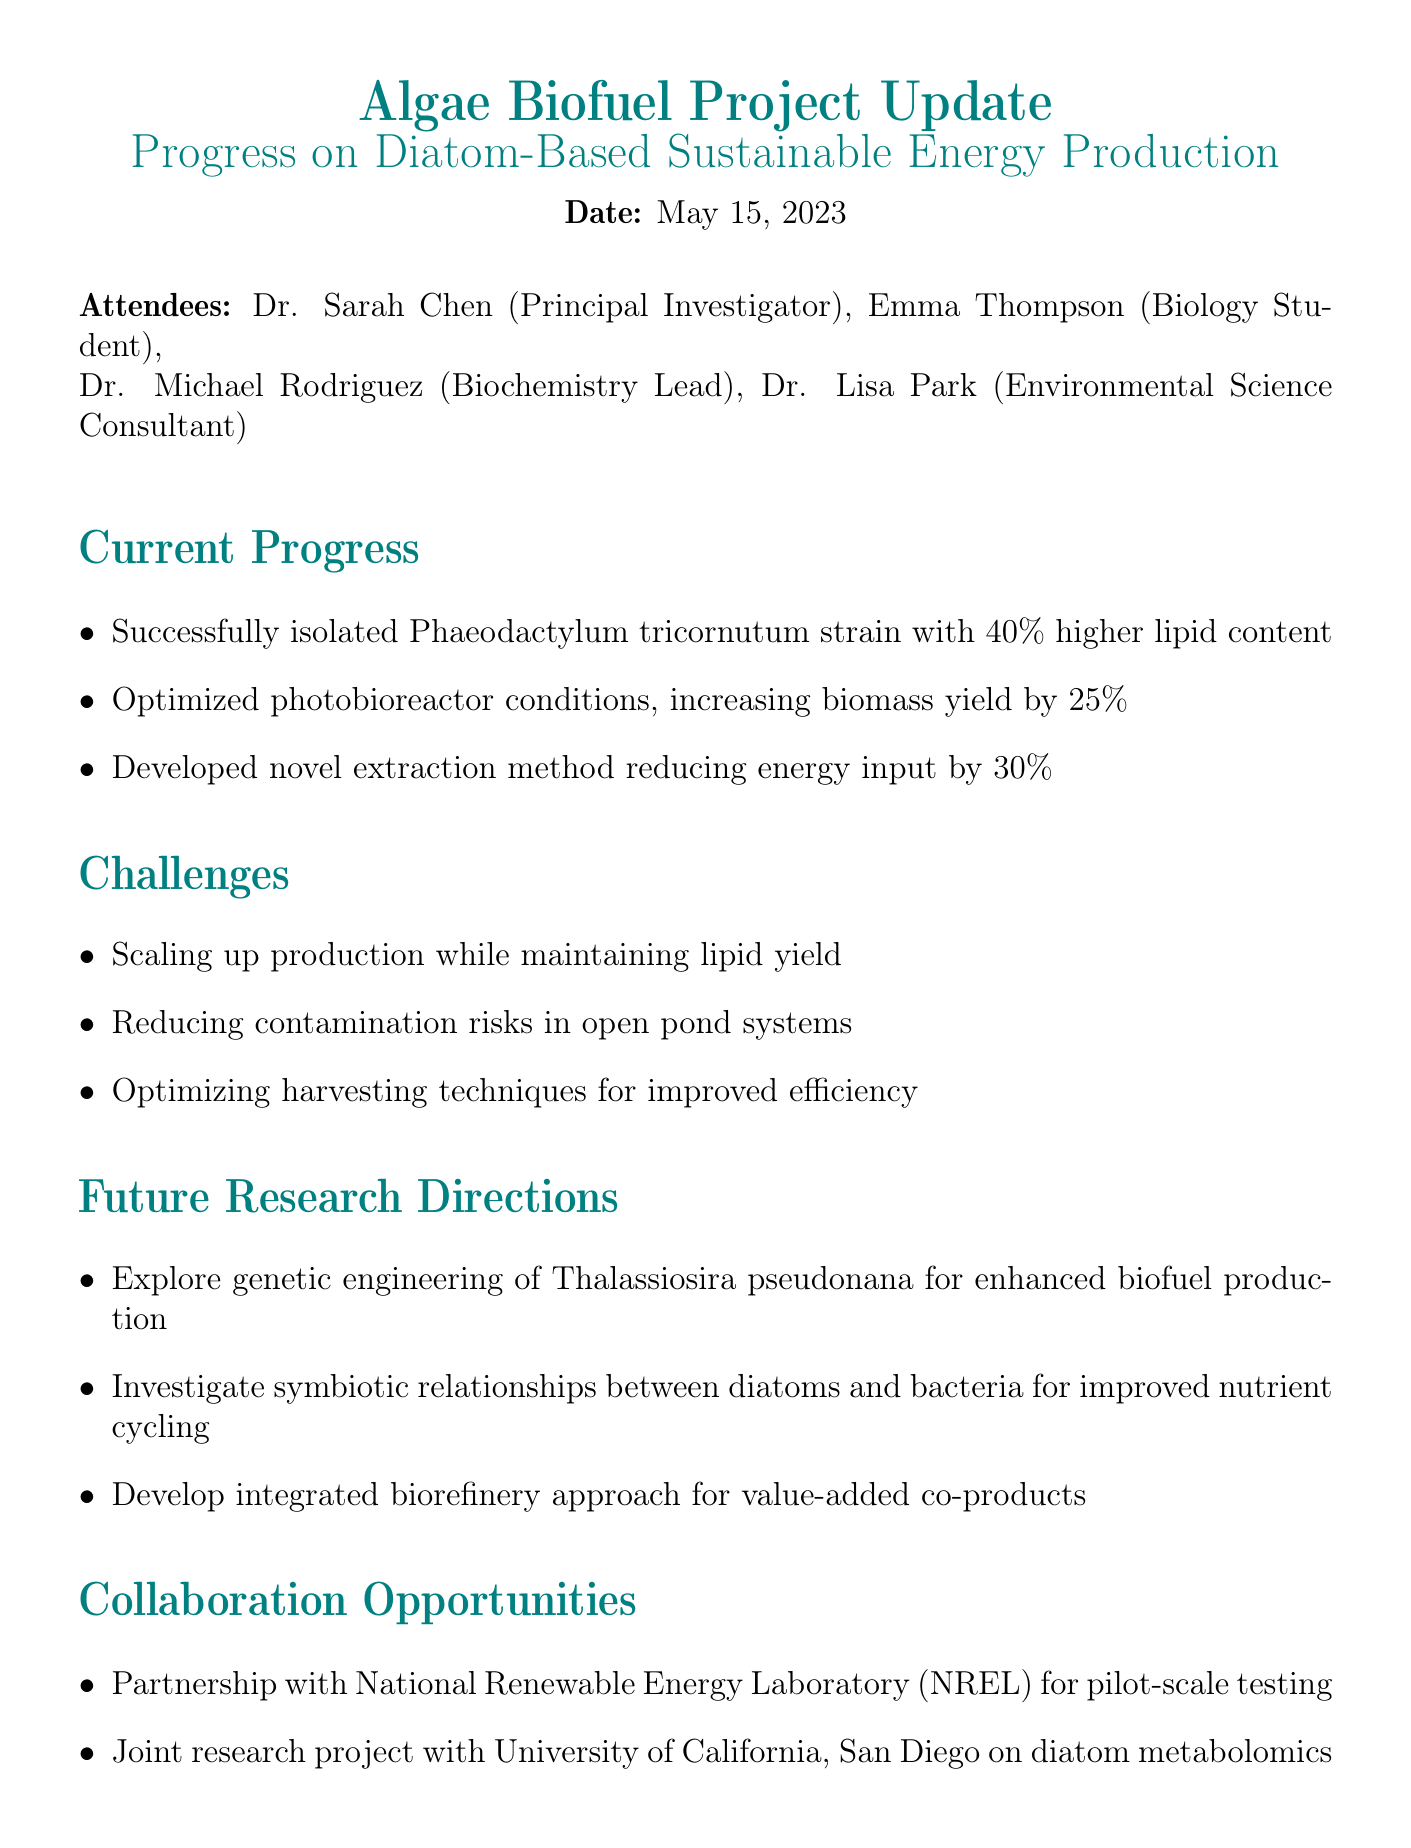What is the date of the meeting? The date of the meeting is explicitly stated in the document.
Answer: May 15, 2023 Who is the Principal Investigator? The document lists attendees, where the Principal Investigator is specifically identified.
Answer: Dr. Sarah Chen What strain of diatom was successfully isolated? The current progress section mentions this specific strain.
Answer: Phaeodactylum tricornutum By what percentage was the biomass yield increased? The increase in biomass yield is detailed in the current progress section.
Answer: 25% What is one of the challenges mentioned in the document? The challenges section lists several issues faced in the project.
Answer: Scaling up production while maintaining lipid yield Which future research direction involves genetic engineering? The future research directions itemizes various new research avenues, including genetic engineering.
Answer: Thalassiosira pseudonana What type of partnership is mentioned for pilot-scale testing? The document lists a specific collaboration opportunity relating to testing.
Answer: National Renewable Energy Laboratory (NREL) What is one next step mentioned for the project? The next steps section outlines actions to be taken following the meeting.
Answer: Submit progress report to Department of Energy by June 30, 2023 Who prepared the meeting minutes? The document includes a closing note indicating who prepared it.
Answer: Emma Thompson, Biology Student 